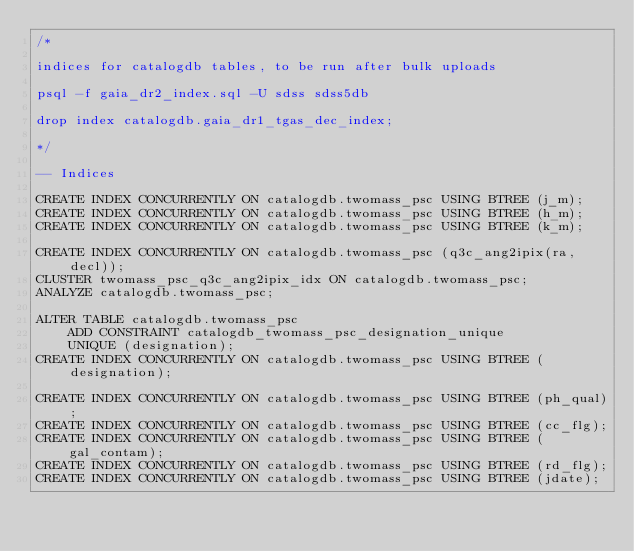<code> <loc_0><loc_0><loc_500><loc_500><_SQL_>/*

indices for catalogdb tables, to be run after bulk uploads

psql -f gaia_dr2_index.sql -U sdss sdss5db

drop index catalogdb.gaia_dr1_tgas_dec_index;

*/

-- Indices

CREATE INDEX CONCURRENTLY ON catalogdb.twomass_psc USING BTREE (j_m);
CREATE INDEX CONCURRENTLY ON catalogdb.twomass_psc USING BTREE (h_m);
CREATE INDEX CONCURRENTLY ON catalogdb.twomass_psc USING BTREE (k_m);

CREATE INDEX CONCURRENTLY ON catalogdb.twomass_psc (q3c_ang2ipix(ra, decl));
CLUSTER twomass_psc_q3c_ang2ipix_idx ON catalogdb.twomass_psc;
ANALYZE catalogdb.twomass_psc;

ALTER TABLE catalogdb.twomass_psc
    ADD CONSTRAINT catalogdb_twomass_psc_designation_unique
    UNIQUE (designation);
CREATE INDEX CONCURRENTLY ON catalogdb.twomass_psc USING BTREE (designation);

CREATE INDEX CONCURRENTLY ON catalogdb.twomass_psc USING BTREE (ph_qual);
CREATE INDEX CONCURRENTLY ON catalogdb.twomass_psc USING BTREE (cc_flg);
CREATE INDEX CONCURRENTLY ON catalogdb.twomass_psc USING BTREE (gal_contam);
CREATE INDEX CONCURRENTLY ON catalogdb.twomass_psc USING BTREE (rd_flg);
CREATE INDEX CONCURRENTLY ON catalogdb.twomass_psc USING BTREE (jdate);
</code> 